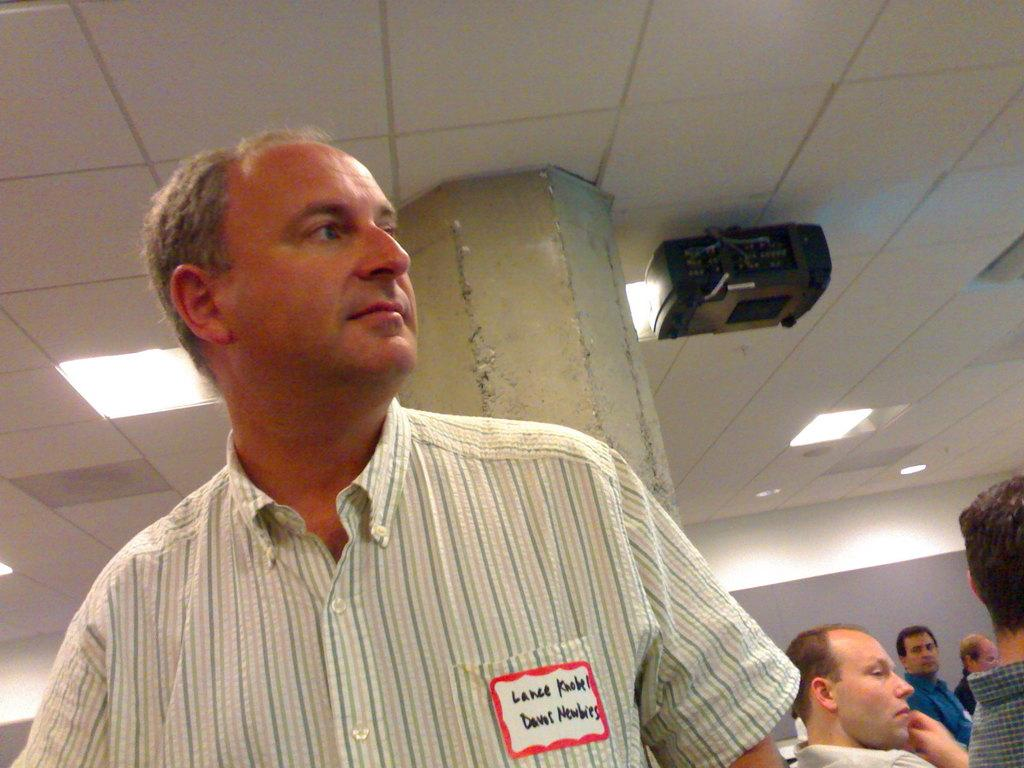How many people are in the image? There is a group of people in the image, but the exact number cannot be determined from the provided facts. What are the people in the image doing? The people are on the floor, but their specific activity is not mentioned in the facts. What can be seen in the background of the image? There is a pillar, a rooftop, and a projector in the background of the image. Where might this image have been taken? The image may have been taken in a hall, based on the presence of a rooftop and a projector in the background. How many legs does the minister have in the image? There is no minister present in the image, so it is not possible to determine the number of legs they might have. 